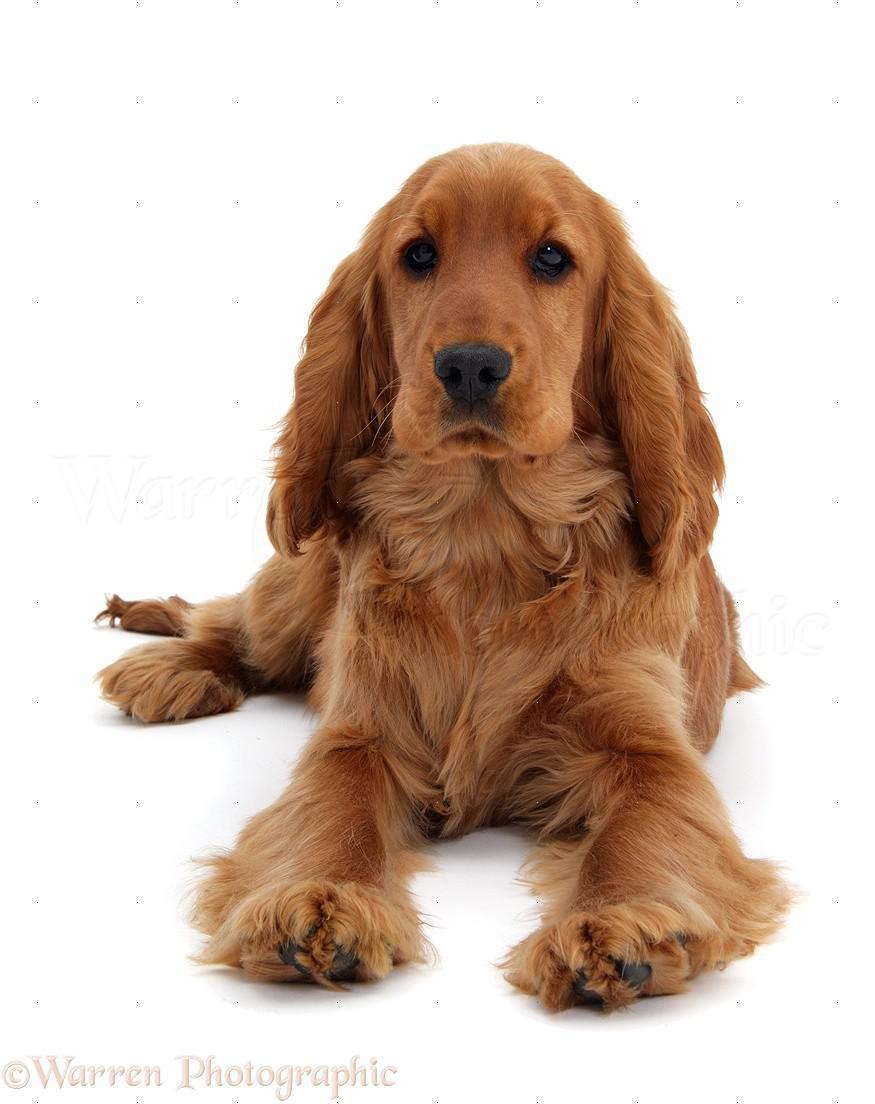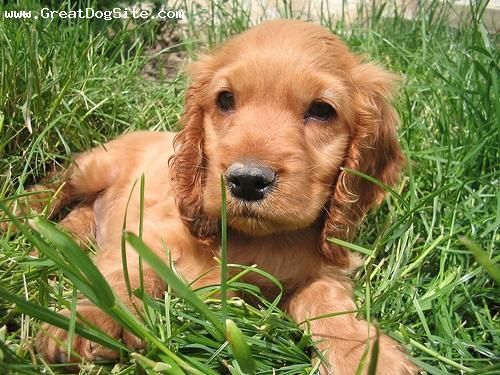The first image is the image on the left, the second image is the image on the right. For the images shown, is this caption "An image contains exactly two dogs." true? Answer yes or no. No. The first image is the image on the left, the second image is the image on the right. Analyze the images presented: Is the assertion "One image contains one forward-facing orange spaniel with wet fur, posed in front of the ocean." valid? Answer yes or no. No. 